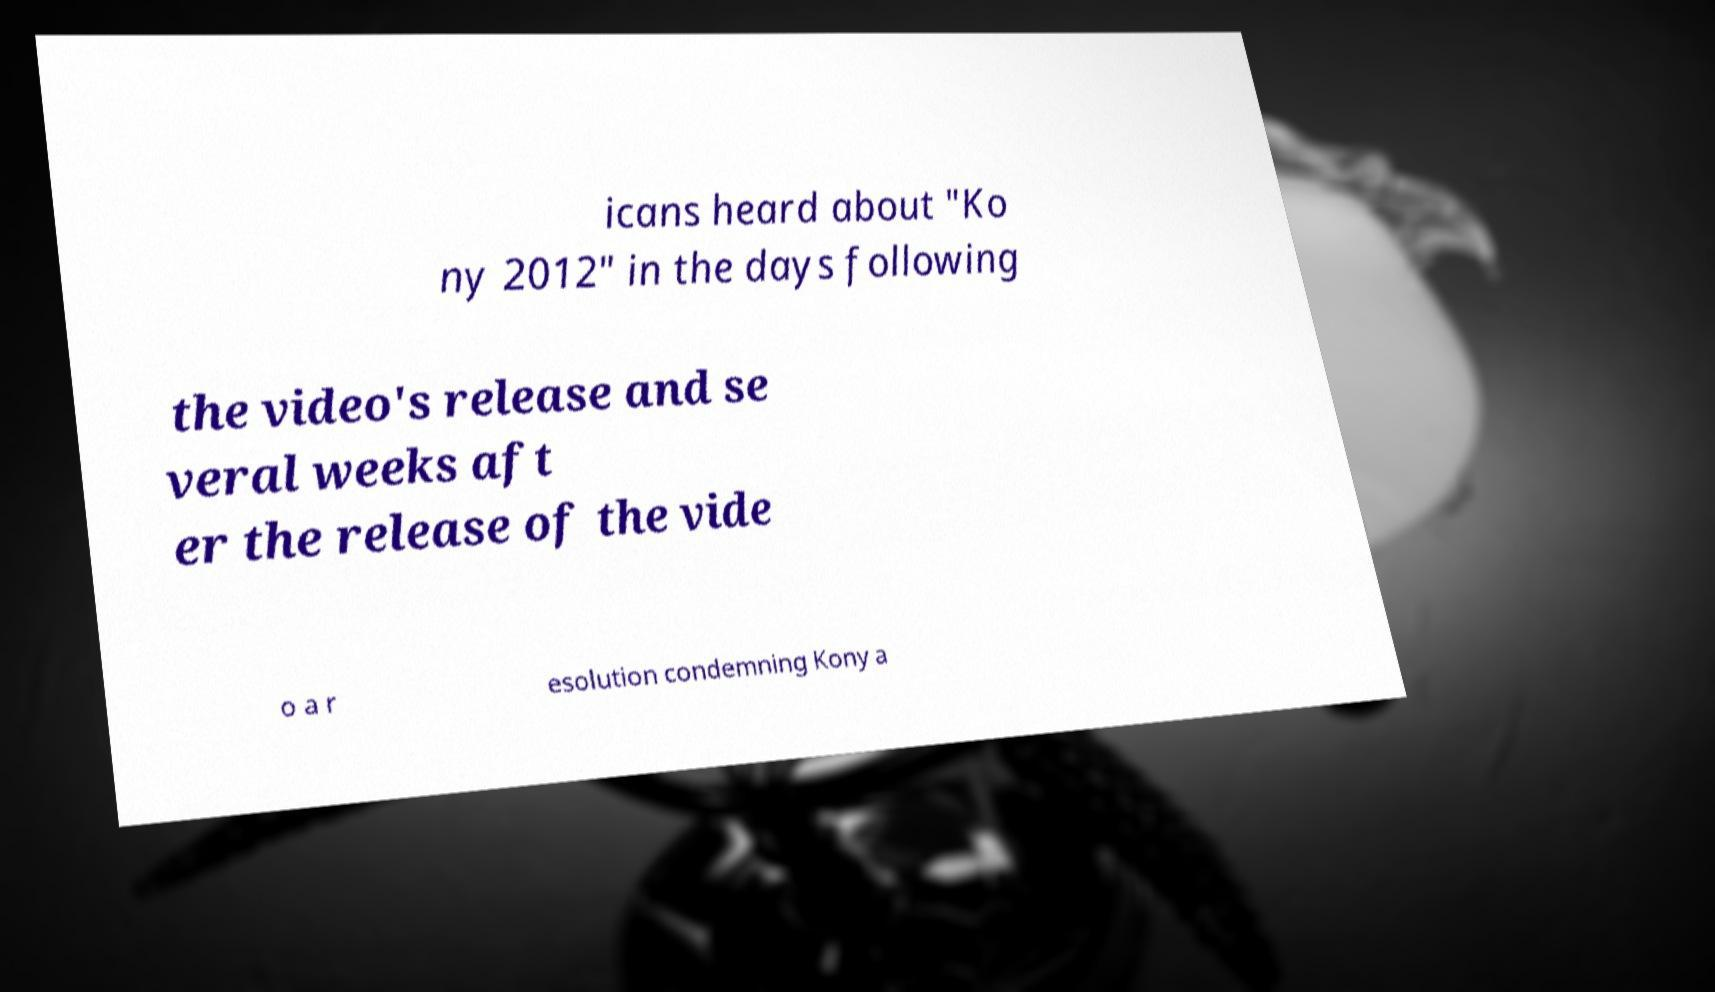I need the written content from this picture converted into text. Can you do that? icans heard about "Ko ny 2012" in the days following the video's release and se veral weeks aft er the release of the vide o a r esolution condemning Kony a 